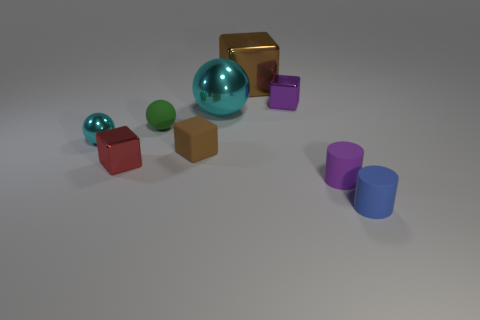The tiny shiny thing that is to the right of the shiny object in front of the small cyan object is what shape?
Your answer should be compact. Cube. Is there any other thing that is the same color as the matte sphere?
Offer a very short reply. No. The tiny purple object that is in front of the large shiny ball has what shape?
Your answer should be very brief. Cylinder. There is a matte object that is both to the right of the green ball and left of the big cyan object; what is its shape?
Give a very brief answer. Cube. How many brown objects are large blocks or big rubber spheres?
Offer a terse response. 1. Does the large metal thing that is behind the tiny purple cube have the same color as the large sphere?
Your answer should be very brief. No. There is a cyan metal sphere on the left side of the small green thing behind the blue matte cylinder; what size is it?
Offer a terse response. Small. What is the material of the cyan object that is the same size as the green ball?
Provide a succinct answer. Metal. How many other things are there of the same size as the brown rubber object?
Keep it short and to the point. 6. How many cylinders are green matte objects or tiny red things?
Offer a terse response. 0. 